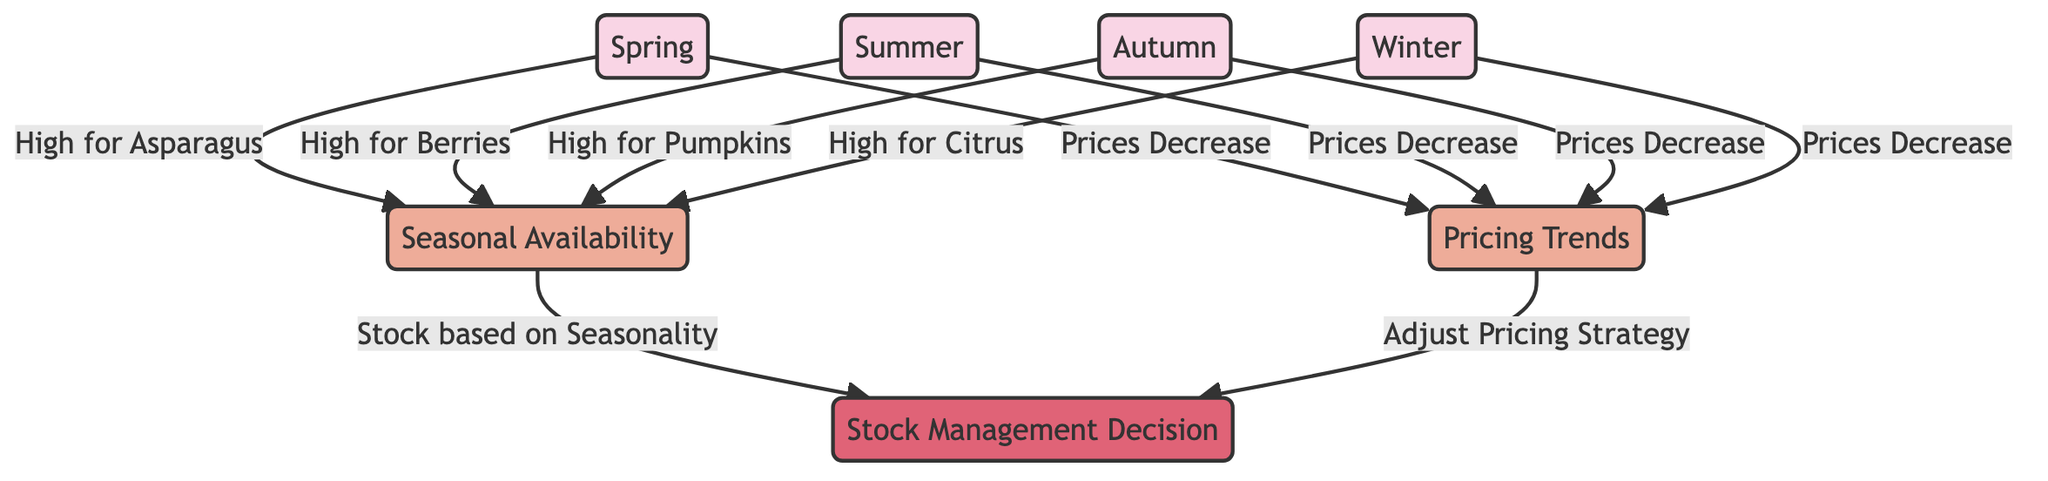What do we see during spring in terms of food availability? The diagram indicates that asparagus has a high availability during the spring season. From the spring node, there is an arrow leading to the availability node, labeled "High for Asparagus," indicating the specific food item that is most available during this season.
Answer: High for Asparagus What seasonal food has high availability in autumn? The diagram shows that pumpkins have high availability in the autumn season. This can be inferred from the autumn node which points to the availability node, labeled "High for Pumpkins."
Answer: High for Pumpkins How do pricing trends behave across all seasons? The diagram illustrates that across all four seasons, the pricing trend shows a decrease. Each season (spring, summer, autumn, winter) has an arrow pointing to the pricing node, with the label "Prices Decrease," demonstrating a consistent trend.
Answer: Prices Decrease Which factor influences stock management decisions based on seasonal availability? The diagram indicates that seasonal availability directly influences the decision-making regarding stock management. There is a connection from the availability node to the decision node, labeled "Stock based on Seasonality," which clearly outlines this relationship.
Answer: Stock based on Seasonality How many seasonal influences are present in the diagram? The diagram lists four seasonal influences: spring, summer, autumn, and winter. Each season is a distinct node in the diagram, making the total count of seasonal entries four.
Answer: 4 What is the connection between pricing and stock management decisions? The diagram shows that pricing trends influence stock management decisions. There is an arrow leading from the pricing node to the decision node, labeled "Adjust Pricing Strategy," indicating that pricing impacts how stock is managed.
Answer: Adjust Pricing Strategy What type of foods are mentioned for winter availability? According to the diagram, citrus is the food specified for high availability during the winter season. This is indicated by the arrow from the winter node to the availability node, which states "High for Citrus."
Answer: High for Citrus What overall impact do seasons have on pricing strategy? The diagram clearly shows that all seasons contribute to a pricing trend of decrease, which would impact the overall pricing strategy the boutique might adopt in response to seasonal fluctuations. Thus, seasonal impacts are significant as pricing consistently decreases.
Answer: Prices Decrease 